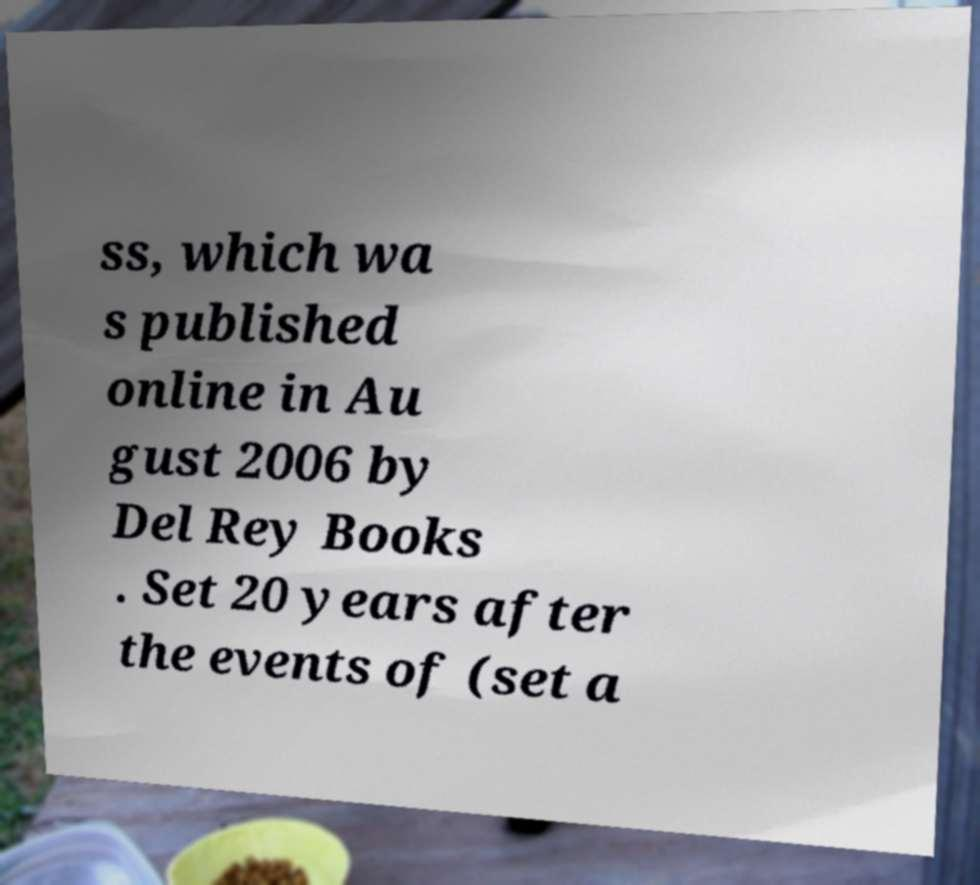Could you extract and type out the text from this image? ss, which wa s published online in Au gust 2006 by Del Rey Books . Set 20 years after the events of (set a 